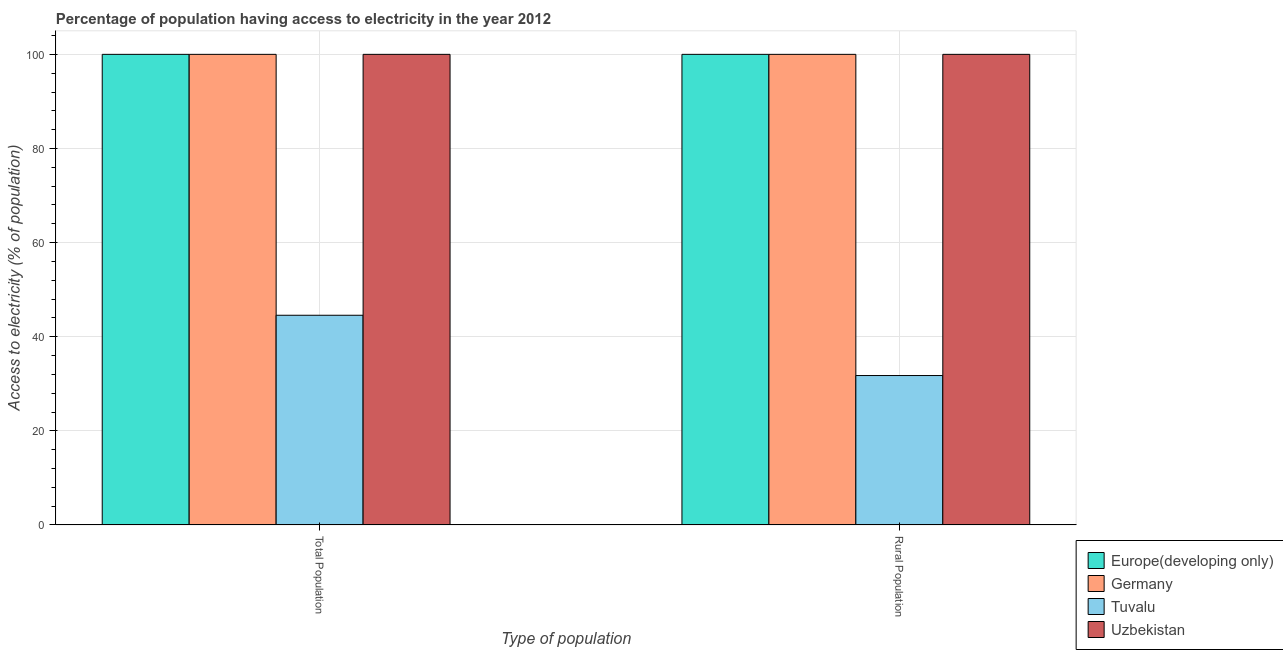How many different coloured bars are there?
Your answer should be very brief. 4. Are the number of bars per tick equal to the number of legend labels?
Offer a terse response. Yes. How many bars are there on the 2nd tick from the right?
Offer a terse response. 4. What is the label of the 2nd group of bars from the left?
Give a very brief answer. Rural Population. Across all countries, what is the maximum percentage of rural population having access to electricity?
Provide a succinct answer. 100. Across all countries, what is the minimum percentage of rural population having access to electricity?
Offer a terse response. 31.75. In which country was the percentage of population having access to electricity maximum?
Provide a succinct answer. Europe(developing only). In which country was the percentage of population having access to electricity minimum?
Your response must be concise. Tuvalu. What is the total percentage of population having access to electricity in the graph?
Your answer should be compact. 344.56. What is the difference between the percentage of population having access to electricity in Germany and that in Tuvalu?
Keep it short and to the point. 55.44. What is the difference between the percentage of population having access to electricity in Tuvalu and the percentage of rural population having access to electricity in Europe(developing only)?
Provide a succinct answer. -55.44. What is the average percentage of population having access to electricity per country?
Provide a short and direct response. 86.14. In how many countries, is the percentage of population having access to electricity greater than 48 %?
Your response must be concise. 3. In how many countries, is the percentage of population having access to electricity greater than the average percentage of population having access to electricity taken over all countries?
Make the answer very short. 3. What does the 4th bar from the left in Rural Population represents?
Provide a succinct answer. Uzbekistan. What does the 1st bar from the right in Rural Population represents?
Offer a terse response. Uzbekistan. How many countries are there in the graph?
Provide a succinct answer. 4. What is the difference between two consecutive major ticks on the Y-axis?
Your response must be concise. 20. Are the values on the major ticks of Y-axis written in scientific E-notation?
Your answer should be very brief. No. Does the graph contain any zero values?
Keep it short and to the point. No. How many legend labels are there?
Ensure brevity in your answer.  4. How are the legend labels stacked?
Offer a very short reply. Vertical. What is the title of the graph?
Offer a terse response. Percentage of population having access to electricity in the year 2012. What is the label or title of the X-axis?
Ensure brevity in your answer.  Type of population. What is the label or title of the Y-axis?
Offer a very short reply. Access to electricity (% of population). What is the Access to electricity (% of population) in Europe(developing only) in Total Population?
Your answer should be compact. 100. What is the Access to electricity (% of population) in Tuvalu in Total Population?
Your answer should be very brief. 44.56. What is the Access to electricity (% of population) in Germany in Rural Population?
Offer a terse response. 100. What is the Access to electricity (% of population) in Tuvalu in Rural Population?
Your answer should be compact. 31.75. What is the Access to electricity (% of population) in Uzbekistan in Rural Population?
Offer a terse response. 100. Across all Type of population, what is the maximum Access to electricity (% of population) of Europe(developing only)?
Offer a very short reply. 100. Across all Type of population, what is the maximum Access to electricity (% of population) of Germany?
Your answer should be compact. 100. Across all Type of population, what is the maximum Access to electricity (% of population) of Tuvalu?
Offer a very short reply. 44.56. Across all Type of population, what is the minimum Access to electricity (% of population) of Germany?
Ensure brevity in your answer.  100. Across all Type of population, what is the minimum Access to electricity (% of population) in Tuvalu?
Ensure brevity in your answer.  31.75. What is the total Access to electricity (% of population) of Europe(developing only) in the graph?
Your answer should be compact. 200. What is the total Access to electricity (% of population) in Tuvalu in the graph?
Keep it short and to the point. 76.32. What is the difference between the Access to electricity (% of population) in Germany in Total Population and that in Rural Population?
Give a very brief answer. 0. What is the difference between the Access to electricity (% of population) in Tuvalu in Total Population and that in Rural Population?
Keep it short and to the point. 12.81. What is the difference between the Access to electricity (% of population) of Uzbekistan in Total Population and that in Rural Population?
Your response must be concise. 0. What is the difference between the Access to electricity (% of population) in Europe(developing only) in Total Population and the Access to electricity (% of population) in Tuvalu in Rural Population?
Keep it short and to the point. 68.25. What is the difference between the Access to electricity (% of population) in Europe(developing only) in Total Population and the Access to electricity (% of population) in Uzbekistan in Rural Population?
Offer a terse response. 0. What is the difference between the Access to electricity (% of population) in Germany in Total Population and the Access to electricity (% of population) in Tuvalu in Rural Population?
Make the answer very short. 68.25. What is the difference between the Access to electricity (% of population) of Germany in Total Population and the Access to electricity (% of population) of Uzbekistan in Rural Population?
Offer a very short reply. 0. What is the difference between the Access to electricity (% of population) in Tuvalu in Total Population and the Access to electricity (% of population) in Uzbekistan in Rural Population?
Keep it short and to the point. -55.44. What is the average Access to electricity (% of population) of Germany per Type of population?
Give a very brief answer. 100. What is the average Access to electricity (% of population) in Tuvalu per Type of population?
Keep it short and to the point. 38.16. What is the average Access to electricity (% of population) in Uzbekistan per Type of population?
Give a very brief answer. 100. What is the difference between the Access to electricity (% of population) in Europe(developing only) and Access to electricity (% of population) in Germany in Total Population?
Ensure brevity in your answer.  0. What is the difference between the Access to electricity (% of population) of Europe(developing only) and Access to electricity (% of population) of Tuvalu in Total Population?
Provide a succinct answer. 55.44. What is the difference between the Access to electricity (% of population) in Germany and Access to electricity (% of population) in Tuvalu in Total Population?
Ensure brevity in your answer.  55.44. What is the difference between the Access to electricity (% of population) of Tuvalu and Access to electricity (% of population) of Uzbekistan in Total Population?
Give a very brief answer. -55.44. What is the difference between the Access to electricity (% of population) in Europe(developing only) and Access to electricity (% of population) in Germany in Rural Population?
Offer a terse response. 0. What is the difference between the Access to electricity (% of population) of Europe(developing only) and Access to electricity (% of population) of Tuvalu in Rural Population?
Give a very brief answer. 68.25. What is the difference between the Access to electricity (% of population) in Germany and Access to electricity (% of population) in Tuvalu in Rural Population?
Give a very brief answer. 68.25. What is the difference between the Access to electricity (% of population) of Germany and Access to electricity (% of population) of Uzbekistan in Rural Population?
Your answer should be very brief. 0. What is the difference between the Access to electricity (% of population) of Tuvalu and Access to electricity (% of population) of Uzbekistan in Rural Population?
Offer a terse response. -68.25. What is the ratio of the Access to electricity (% of population) in Tuvalu in Total Population to that in Rural Population?
Make the answer very short. 1.4. What is the difference between the highest and the second highest Access to electricity (% of population) in Germany?
Provide a succinct answer. 0. What is the difference between the highest and the second highest Access to electricity (% of population) in Tuvalu?
Your answer should be very brief. 12.81. What is the difference between the highest and the second highest Access to electricity (% of population) in Uzbekistan?
Your response must be concise. 0. What is the difference between the highest and the lowest Access to electricity (% of population) in Tuvalu?
Offer a terse response. 12.81. 